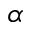<formula> <loc_0><loc_0><loc_500><loc_500>\alpha</formula> 